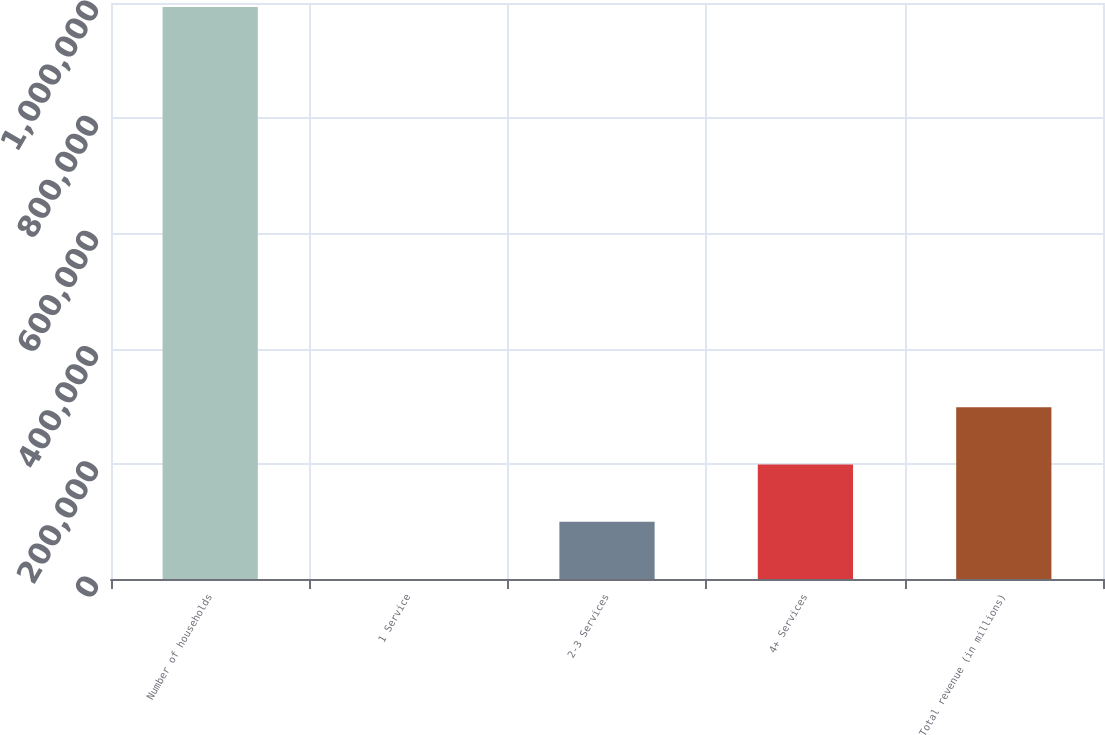Convert chart. <chart><loc_0><loc_0><loc_500><loc_500><bar_chart><fcel>Number of households<fcel>1 Service<fcel>2-3 Services<fcel>4+ Services<fcel>Total revenue (in millions)<nl><fcel>993272<fcel>5.3<fcel>99332<fcel>198659<fcel>297985<nl></chart> 